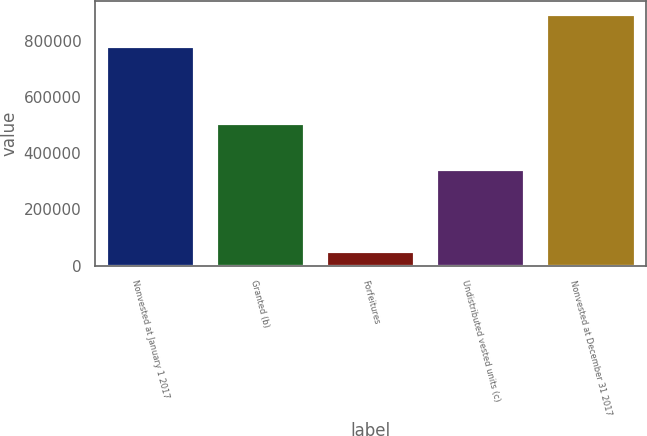<chart> <loc_0><loc_0><loc_500><loc_500><bar_chart><fcel>Nonvested at January 1 2017<fcel>Granted (b)<fcel>Forfeitures<fcel>Undistributed vested units (c)<fcel>Nonvested at December 31 2017<nl><fcel>780545<fcel>508161<fcel>50523<fcel>342694<fcel>895489<nl></chart> 